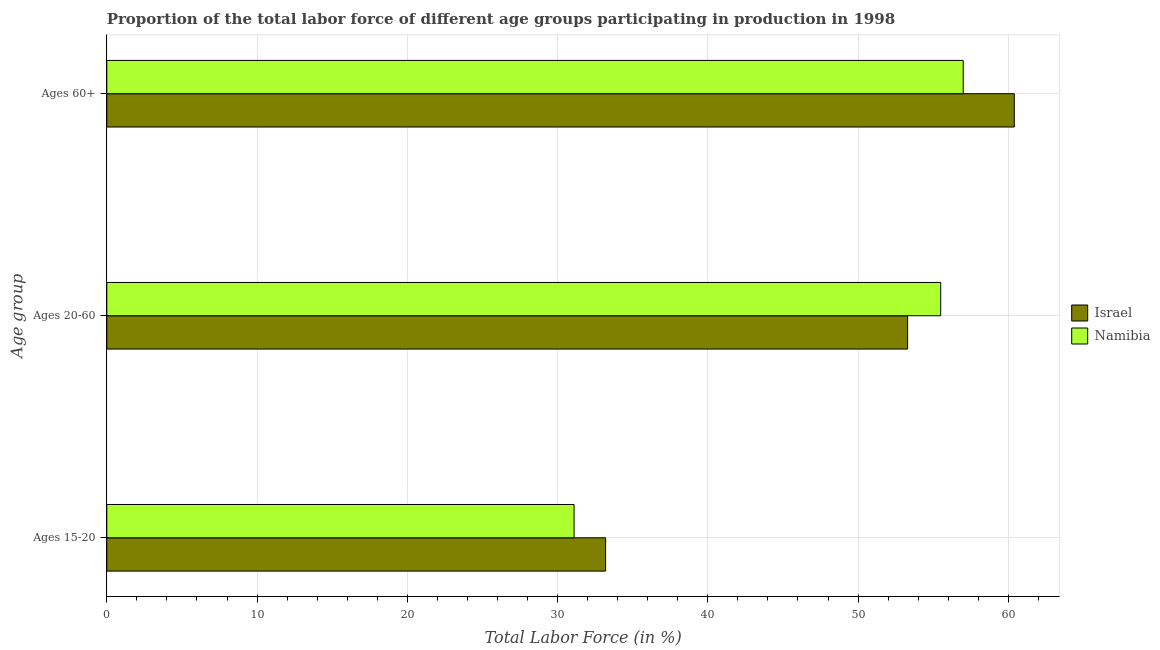Are the number of bars per tick equal to the number of legend labels?
Keep it short and to the point. Yes. Are the number of bars on each tick of the Y-axis equal?
Offer a terse response. Yes. What is the label of the 3rd group of bars from the top?
Keep it short and to the point. Ages 15-20. Across all countries, what is the maximum percentage of labor force within the age group 20-60?
Your response must be concise. 55.5. Across all countries, what is the minimum percentage of labor force above age 60?
Provide a succinct answer. 57. In which country was the percentage of labor force within the age group 15-20 minimum?
Provide a short and direct response. Namibia. What is the total percentage of labor force above age 60 in the graph?
Offer a very short reply. 117.4. What is the difference between the percentage of labor force within the age group 20-60 in Israel and that in Namibia?
Make the answer very short. -2.2. What is the difference between the percentage of labor force within the age group 15-20 in Israel and the percentage of labor force above age 60 in Namibia?
Your answer should be very brief. -23.8. What is the average percentage of labor force within the age group 15-20 per country?
Your answer should be compact. 32.15. What is the difference between the percentage of labor force within the age group 15-20 and percentage of labor force within the age group 20-60 in Israel?
Provide a succinct answer. -20.1. In how many countries, is the percentage of labor force above age 60 greater than 40 %?
Give a very brief answer. 2. What is the ratio of the percentage of labor force within the age group 15-20 in Israel to that in Namibia?
Offer a very short reply. 1.07. What is the difference between the highest and the second highest percentage of labor force within the age group 20-60?
Your response must be concise. 2.2. What is the difference between the highest and the lowest percentage of labor force above age 60?
Give a very brief answer. 3.4. What does the 1st bar from the top in Ages 60+ represents?
Your response must be concise. Namibia. Is it the case that in every country, the sum of the percentage of labor force within the age group 15-20 and percentage of labor force within the age group 20-60 is greater than the percentage of labor force above age 60?
Offer a terse response. Yes. How many bars are there?
Your response must be concise. 6. What is the difference between two consecutive major ticks on the X-axis?
Make the answer very short. 10. Does the graph contain any zero values?
Provide a succinct answer. No. Where does the legend appear in the graph?
Give a very brief answer. Center right. How many legend labels are there?
Your response must be concise. 2. What is the title of the graph?
Make the answer very short. Proportion of the total labor force of different age groups participating in production in 1998. What is the label or title of the Y-axis?
Keep it short and to the point. Age group. What is the Total Labor Force (in %) of Israel in Ages 15-20?
Your response must be concise. 33.2. What is the Total Labor Force (in %) of Namibia in Ages 15-20?
Provide a short and direct response. 31.1. What is the Total Labor Force (in %) in Israel in Ages 20-60?
Make the answer very short. 53.3. What is the Total Labor Force (in %) in Namibia in Ages 20-60?
Provide a succinct answer. 55.5. What is the Total Labor Force (in %) in Israel in Ages 60+?
Make the answer very short. 60.4. What is the Total Labor Force (in %) in Namibia in Ages 60+?
Offer a very short reply. 57. Across all Age group, what is the maximum Total Labor Force (in %) of Israel?
Your response must be concise. 60.4. Across all Age group, what is the maximum Total Labor Force (in %) in Namibia?
Your response must be concise. 57. Across all Age group, what is the minimum Total Labor Force (in %) of Israel?
Offer a terse response. 33.2. Across all Age group, what is the minimum Total Labor Force (in %) in Namibia?
Keep it short and to the point. 31.1. What is the total Total Labor Force (in %) of Israel in the graph?
Your answer should be very brief. 146.9. What is the total Total Labor Force (in %) of Namibia in the graph?
Make the answer very short. 143.6. What is the difference between the Total Labor Force (in %) of Israel in Ages 15-20 and that in Ages 20-60?
Give a very brief answer. -20.1. What is the difference between the Total Labor Force (in %) of Namibia in Ages 15-20 and that in Ages 20-60?
Offer a terse response. -24.4. What is the difference between the Total Labor Force (in %) in Israel in Ages 15-20 and that in Ages 60+?
Your response must be concise. -27.2. What is the difference between the Total Labor Force (in %) of Namibia in Ages 15-20 and that in Ages 60+?
Provide a succinct answer. -25.9. What is the difference between the Total Labor Force (in %) of Israel in Ages 15-20 and the Total Labor Force (in %) of Namibia in Ages 20-60?
Provide a succinct answer. -22.3. What is the difference between the Total Labor Force (in %) of Israel in Ages 15-20 and the Total Labor Force (in %) of Namibia in Ages 60+?
Offer a terse response. -23.8. What is the difference between the Total Labor Force (in %) of Israel in Ages 20-60 and the Total Labor Force (in %) of Namibia in Ages 60+?
Provide a succinct answer. -3.7. What is the average Total Labor Force (in %) in Israel per Age group?
Provide a short and direct response. 48.97. What is the average Total Labor Force (in %) in Namibia per Age group?
Your answer should be compact. 47.87. What is the difference between the Total Labor Force (in %) in Israel and Total Labor Force (in %) in Namibia in Ages 15-20?
Provide a short and direct response. 2.1. What is the difference between the Total Labor Force (in %) in Israel and Total Labor Force (in %) in Namibia in Ages 20-60?
Offer a terse response. -2.2. What is the ratio of the Total Labor Force (in %) in Israel in Ages 15-20 to that in Ages 20-60?
Offer a terse response. 0.62. What is the ratio of the Total Labor Force (in %) of Namibia in Ages 15-20 to that in Ages 20-60?
Provide a succinct answer. 0.56. What is the ratio of the Total Labor Force (in %) in Israel in Ages 15-20 to that in Ages 60+?
Make the answer very short. 0.55. What is the ratio of the Total Labor Force (in %) in Namibia in Ages 15-20 to that in Ages 60+?
Your answer should be compact. 0.55. What is the ratio of the Total Labor Force (in %) in Israel in Ages 20-60 to that in Ages 60+?
Provide a succinct answer. 0.88. What is the ratio of the Total Labor Force (in %) of Namibia in Ages 20-60 to that in Ages 60+?
Your response must be concise. 0.97. What is the difference between the highest and the lowest Total Labor Force (in %) of Israel?
Make the answer very short. 27.2. What is the difference between the highest and the lowest Total Labor Force (in %) of Namibia?
Your response must be concise. 25.9. 